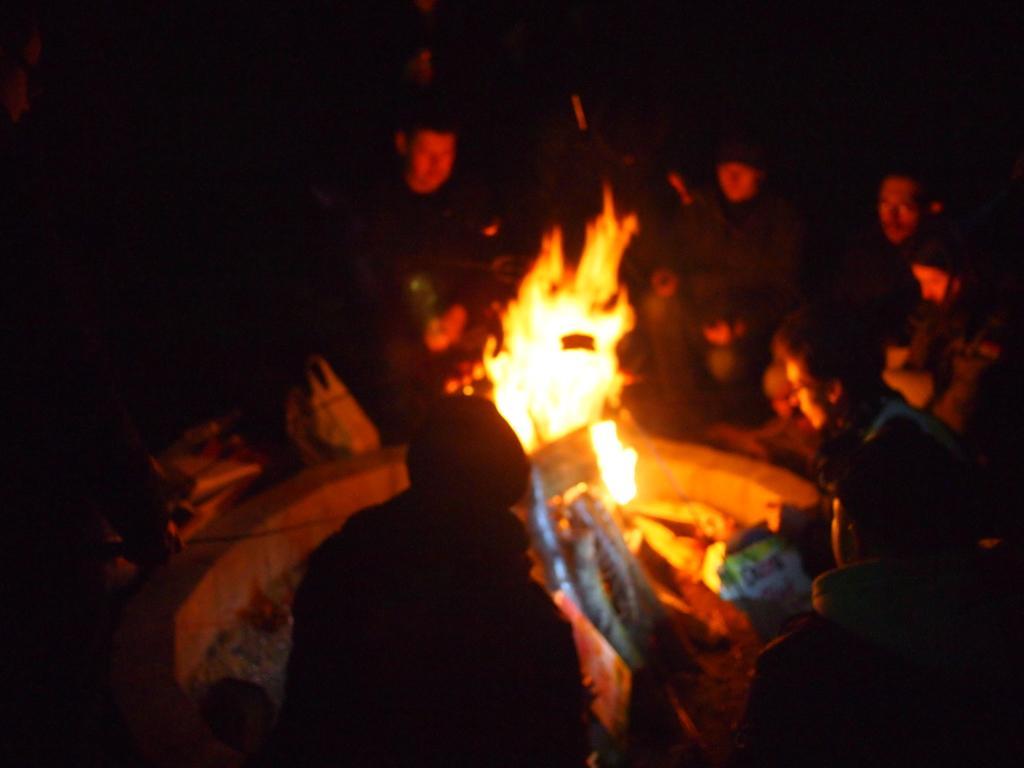Could you give a brief overview of what you see in this image? In this image, we can see a group of people are around the fire. In the middle of the image, we can see few objects. In the background, there is a dark view. 